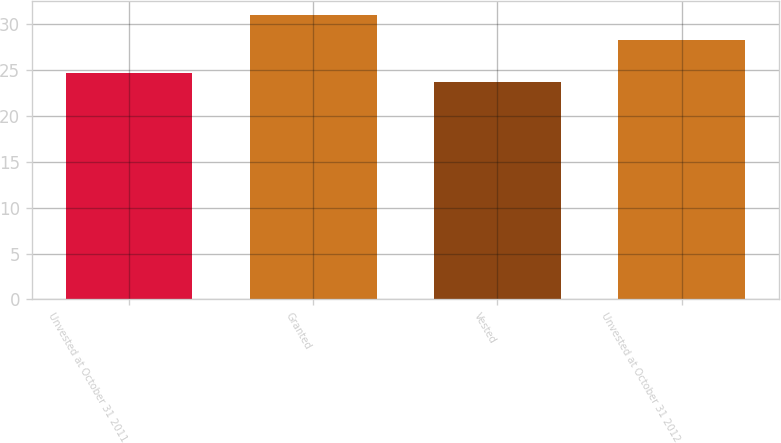Convert chart. <chart><loc_0><loc_0><loc_500><loc_500><bar_chart><fcel>Unvested at October 31 2011<fcel>Granted<fcel>Vested<fcel>Unvested at October 31 2012<nl><fcel>24.73<fcel>31.04<fcel>23.66<fcel>28.28<nl></chart> 